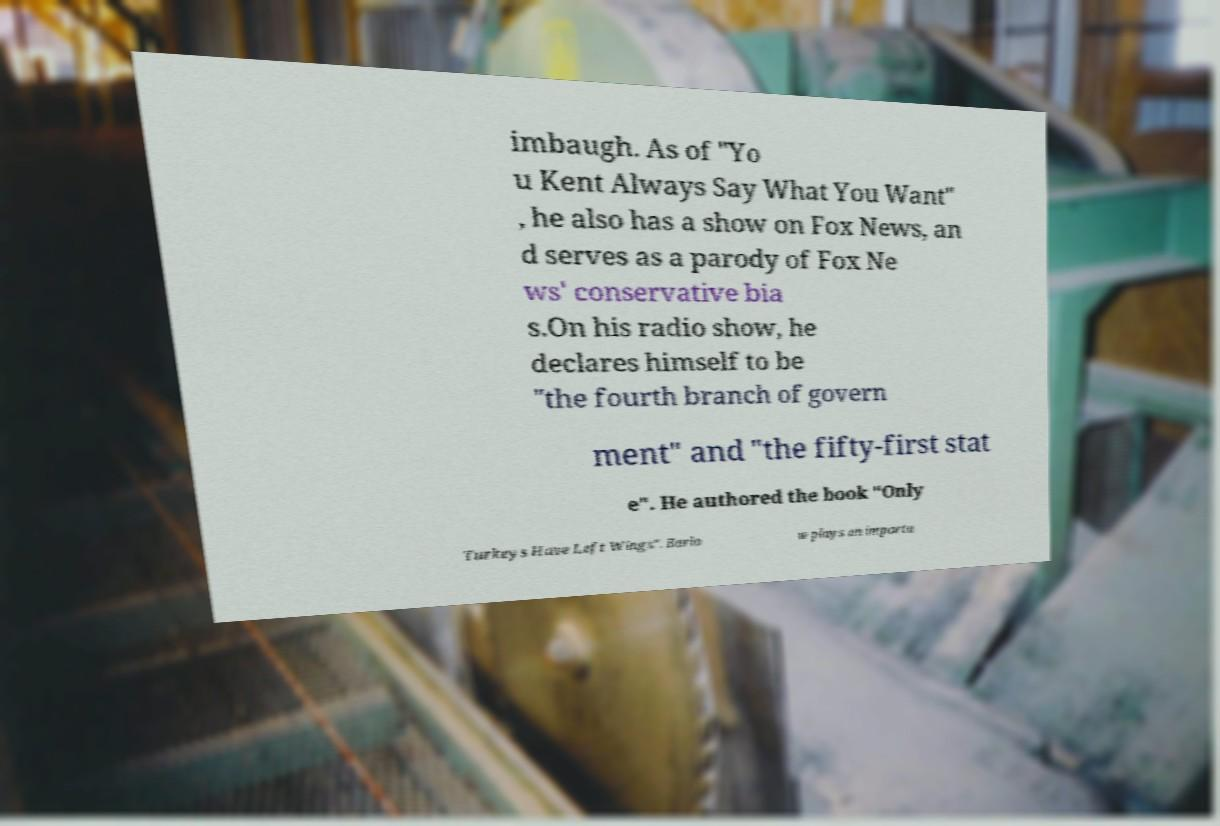For documentation purposes, I need the text within this image transcribed. Could you provide that? imbaugh. As of "Yo u Kent Always Say What You Want" , he also has a show on Fox News, an d serves as a parody of Fox Ne ws' conservative bia s.On his radio show, he declares himself to be "the fourth branch of govern ment" and "the fifty-first stat e". He authored the book "Only Turkeys Have Left Wings". Barlo w plays an importa 